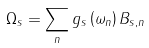Convert formula to latex. <formula><loc_0><loc_0><loc_500><loc_500>\Omega _ { s } = \sum _ { n } g _ { s } \left ( \omega _ { n } \right ) B _ { s , n }</formula> 